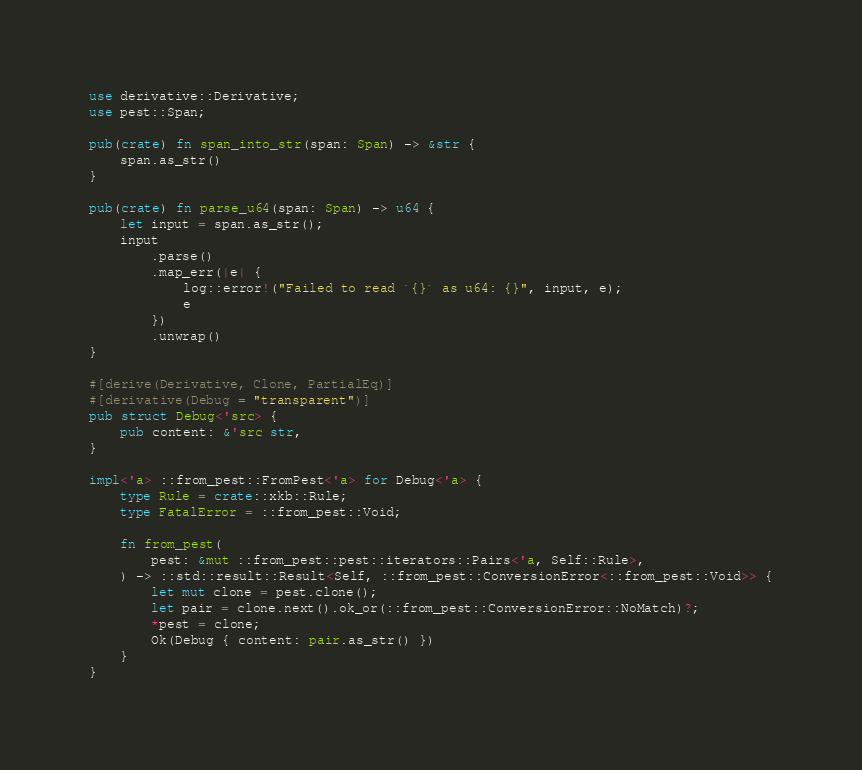<code> <loc_0><loc_0><loc_500><loc_500><_Rust_>use derivative::Derivative;
use pest::Span;

pub(crate) fn span_into_str(span: Span) -> &str {
    span.as_str()
}

pub(crate) fn parse_u64(span: Span) -> u64 {
    let input = span.as_str();
    input
        .parse()
        .map_err(|e| {
            log::error!("Failed to read `{}` as u64: {}", input, e);
            e
        })
        .unwrap()
}

#[derive(Derivative, Clone, PartialEq)]
#[derivative(Debug = "transparent")]
pub struct Debug<'src> {
    pub content: &'src str,
}

impl<'a> ::from_pest::FromPest<'a> for Debug<'a> {
    type Rule = crate::xkb::Rule;
    type FatalError = ::from_pest::Void;

    fn from_pest(
        pest: &mut ::from_pest::pest::iterators::Pairs<'a, Self::Rule>,
    ) -> ::std::result::Result<Self, ::from_pest::ConversionError<::from_pest::Void>> {
        let mut clone = pest.clone();
        let pair = clone.next().ok_or(::from_pest::ConversionError::NoMatch)?;
        *pest = clone;
        Ok(Debug { content: pair.as_str() })
    }
}
</code> 